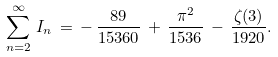<formula> <loc_0><loc_0><loc_500><loc_500>\sum _ { n = 2 } ^ { \infty } \, I _ { n } \, = \, - \, \frac { 8 9 } { 1 5 3 6 0 } \, + \, \frac { \pi ^ { 2 } } { 1 5 3 6 } \, - \, \frac { \zeta ( 3 ) } { 1 9 2 0 } .</formula> 